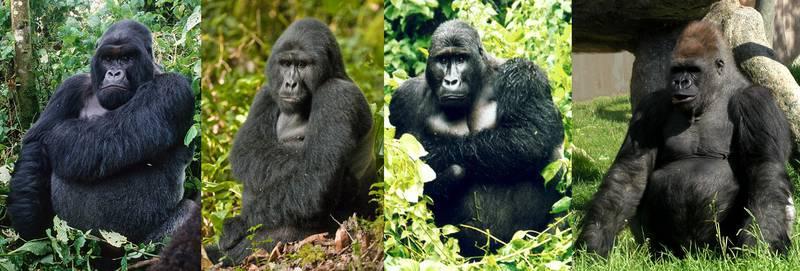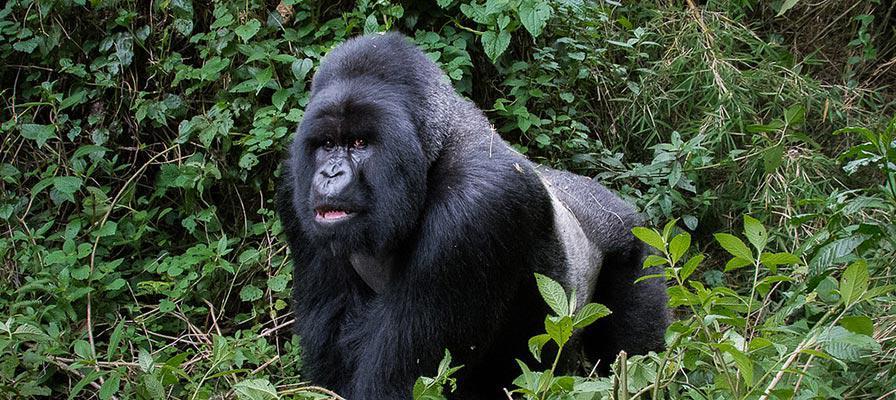The first image is the image on the left, the second image is the image on the right. For the images shown, is this caption "There are no more than two apes in total." true? Answer yes or no. No. The first image is the image on the left, the second image is the image on the right. Considering the images on both sides, is "There are exactly two gorillas in total." valid? Answer yes or no. No. 